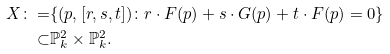Convert formula to latex. <formula><loc_0><loc_0><loc_500><loc_500>X \colon = & \{ ( p , [ r , s , t ] ) \colon r \cdot F ( p ) + s \cdot G ( p ) + t \cdot F ( p ) = 0 \} \\ \subset & \mathbb { P } ^ { 2 } _ { k } \times \mathbb { P } ^ { 2 } _ { k } .</formula> 